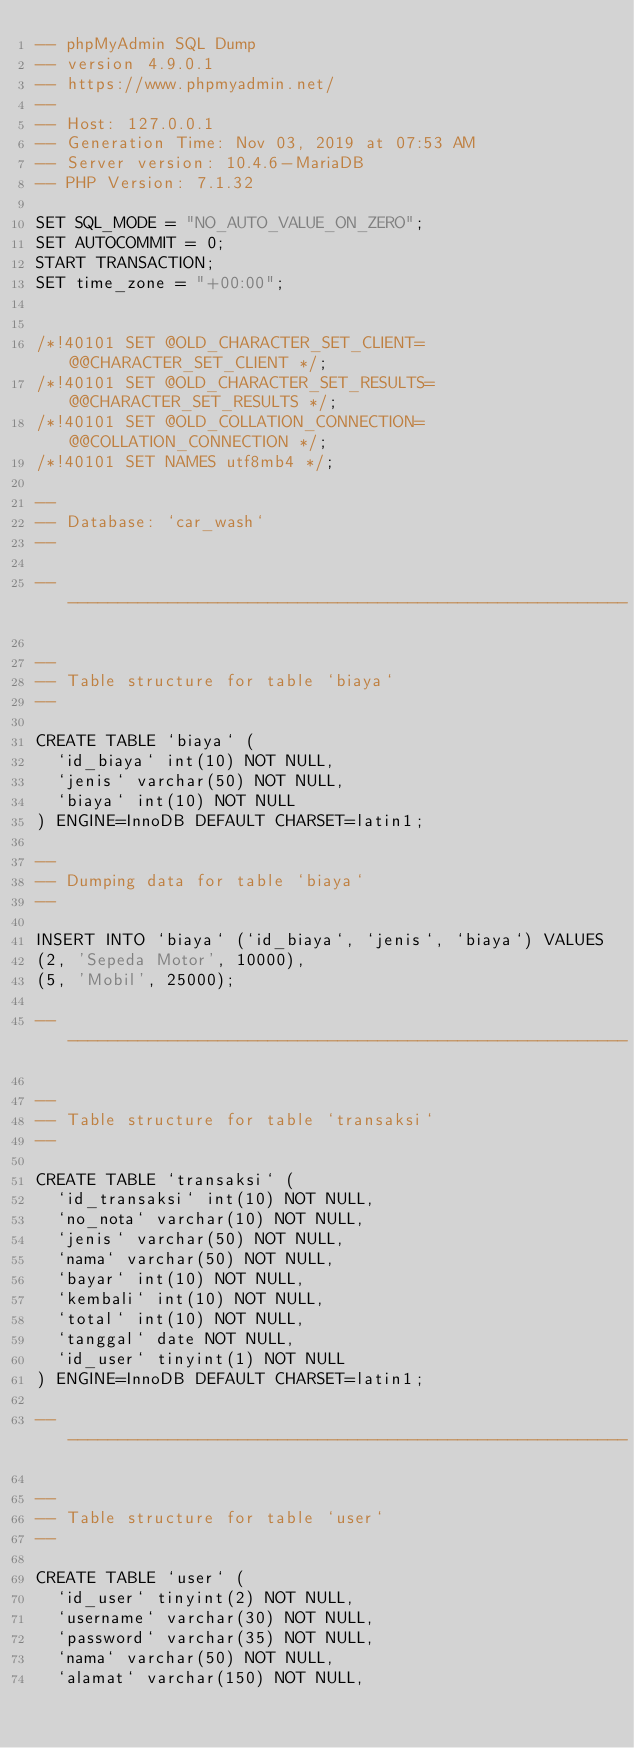<code> <loc_0><loc_0><loc_500><loc_500><_SQL_>-- phpMyAdmin SQL Dump
-- version 4.9.0.1
-- https://www.phpmyadmin.net/
--
-- Host: 127.0.0.1
-- Generation Time: Nov 03, 2019 at 07:53 AM
-- Server version: 10.4.6-MariaDB
-- PHP Version: 7.1.32

SET SQL_MODE = "NO_AUTO_VALUE_ON_ZERO";
SET AUTOCOMMIT = 0;
START TRANSACTION;
SET time_zone = "+00:00";


/*!40101 SET @OLD_CHARACTER_SET_CLIENT=@@CHARACTER_SET_CLIENT */;
/*!40101 SET @OLD_CHARACTER_SET_RESULTS=@@CHARACTER_SET_RESULTS */;
/*!40101 SET @OLD_COLLATION_CONNECTION=@@COLLATION_CONNECTION */;
/*!40101 SET NAMES utf8mb4 */;

--
-- Database: `car_wash`
--

-- --------------------------------------------------------

--
-- Table structure for table `biaya`
--

CREATE TABLE `biaya` (
  `id_biaya` int(10) NOT NULL,
  `jenis` varchar(50) NOT NULL,
  `biaya` int(10) NOT NULL
) ENGINE=InnoDB DEFAULT CHARSET=latin1;

--
-- Dumping data for table `biaya`
--

INSERT INTO `biaya` (`id_biaya`, `jenis`, `biaya`) VALUES
(2, 'Sepeda Motor', 10000),
(5, 'Mobil', 25000);

-- --------------------------------------------------------

--
-- Table structure for table `transaksi`
--

CREATE TABLE `transaksi` (
  `id_transaksi` int(10) NOT NULL,
  `no_nota` varchar(10) NOT NULL,
  `jenis` varchar(50) NOT NULL,
  `nama` varchar(50) NOT NULL,
  `bayar` int(10) NOT NULL,
  `kembali` int(10) NOT NULL,
  `total` int(10) NOT NULL,
  `tanggal` date NOT NULL,
  `id_user` tinyint(1) NOT NULL
) ENGINE=InnoDB DEFAULT CHARSET=latin1;

-- --------------------------------------------------------

--
-- Table structure for table `user`
--

CREATE TABLE `user` (
  `id_user` tinyint(2) NOT NULL,
  `username` varchar(30) NOT NULL,
  `password` varchar(35) NOT NULL,
  `nama` varchar(50) NOT NULL,
  `alamat` varchar(150) NOT NULL,</code> 